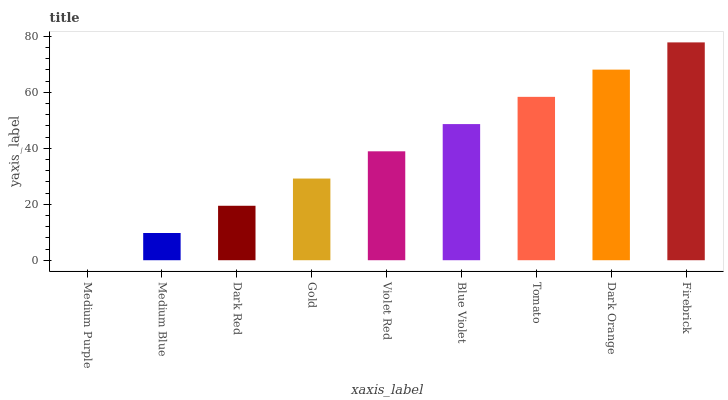Is Medium Purple the minimum?
Answer yes or no. Yes. Is Firebrick the maximum?
Answer yes or no. Yes. Is Medium Blue the minimum?
Answer yes or no. No. Is Medium Blue the maximum?
Answer yes or no. No. Is Medium Blue greater than Medium Purple?
Answer yes or no. Yes. Is Medium Purple less than Medium Blue?
Answer yes or no. Yes. Is Medium Purple greater than Medium Blue?
Answer yes or no. No. Is Medium Blue less than Medium Purple?
Answer yes or no. No. Is Violet Red the high median?
Answer yes or no. Yes. Is Violet Red the low median?
Answer yes or no. Yes. Is Gold the high median?
Answer yes or no. No. Is Gold the low median?
Answer yes or no. No. 